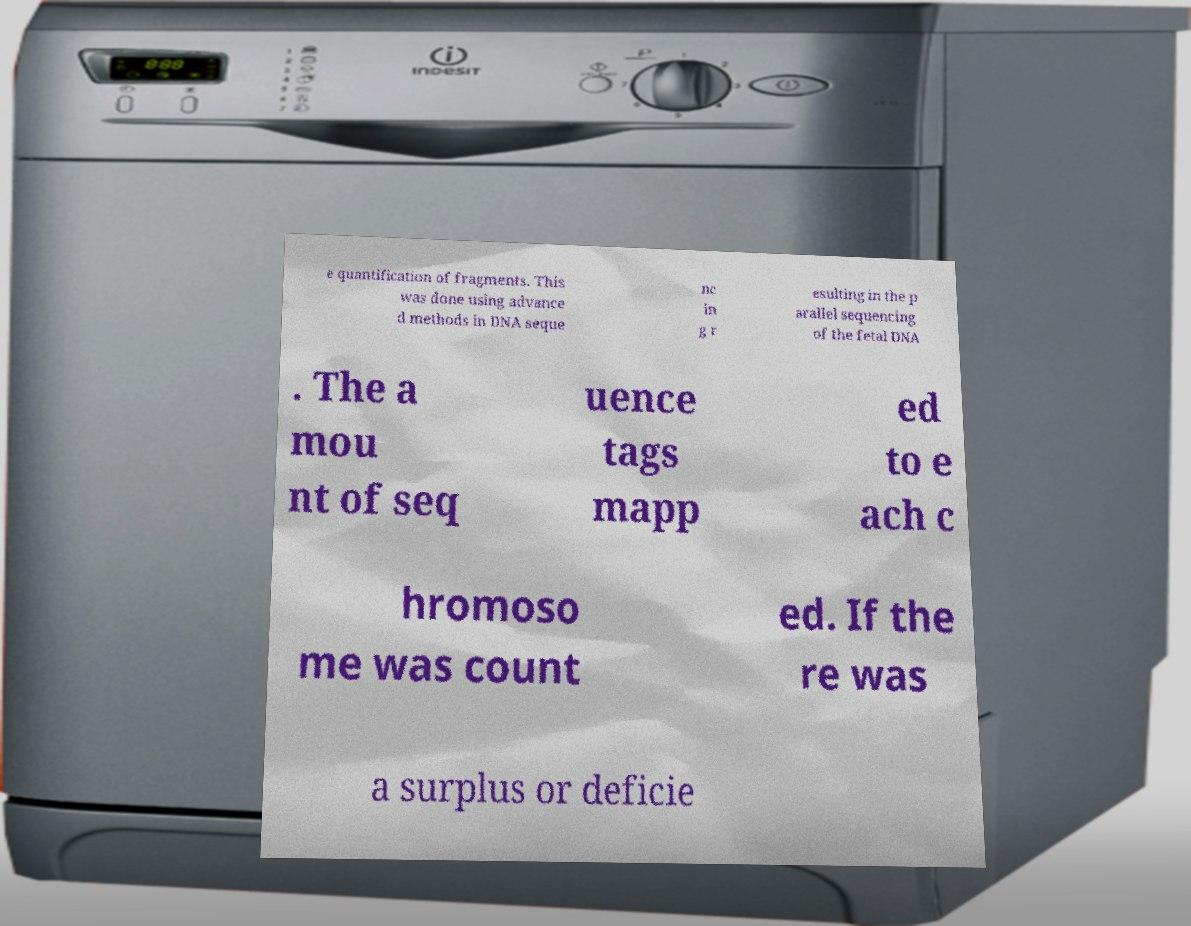I need the written content from this picture converted into text. Can you do that? e quantification of fragments. This was done using advance d methods in DNA seque nc in g r esulting in the p arallel sequencing of the fetal DNA . The a mou nt of seq uence tags mapp ed to e ach c hromoso me was count ed. If the re was a surplus or deficie 